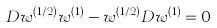Convert formula to latex. <formula><loc_0><loc_0><loc_500><loc_500>D w ^ { ( 1 / 2 ) } w ^ { ( 1 ) } - w ^ { ( 1 / 2 ) } D w ^ { ( 1 ) } = 0</formula> 